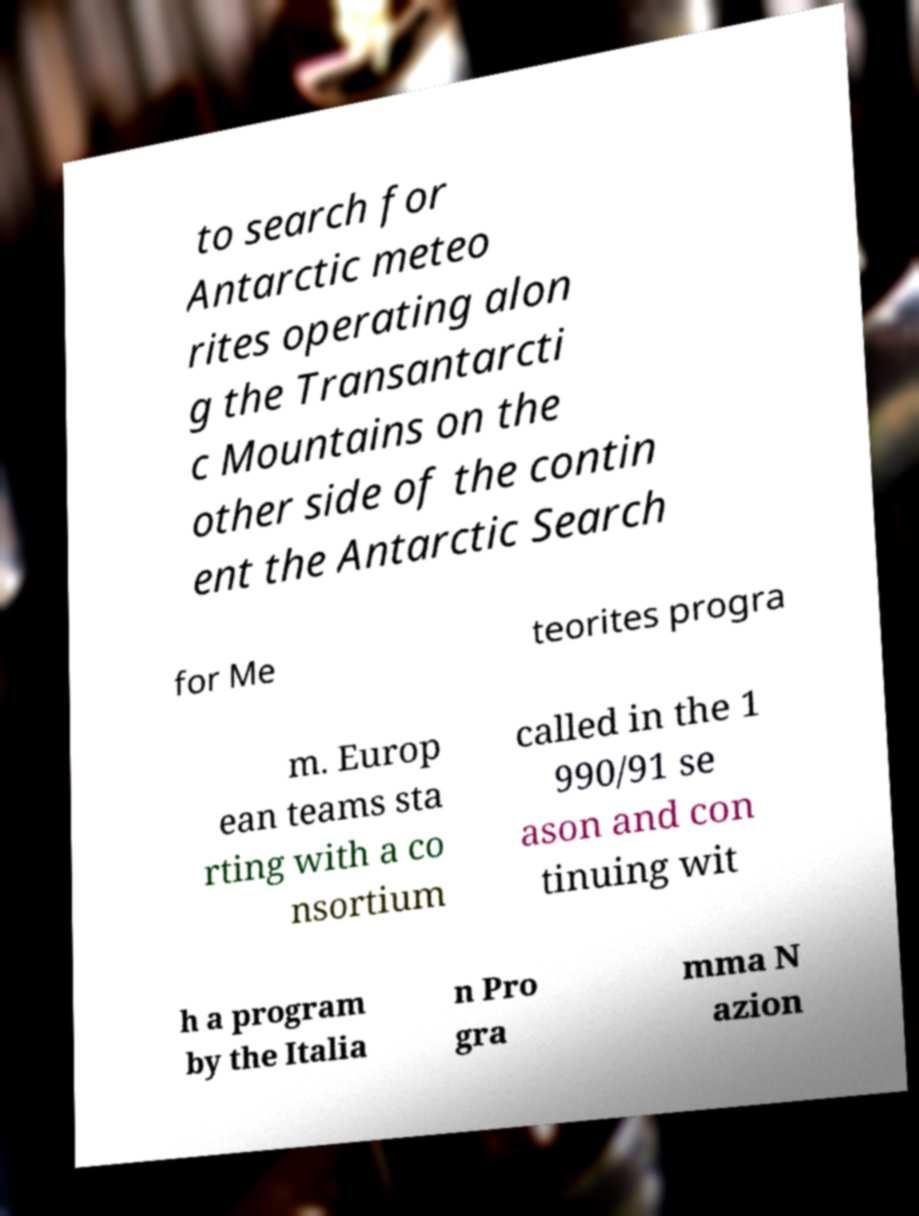Can you accurately transcribe the text from the provided image for me? to search for Antarctic meteo rites operating alon g the Transantarcti c Mountains on the other side of the contin ent the Antarctic Search for Me teorites progra m. Europ ean teams sta rting with a co nsortium called in the 1 990/91 se ason and con tinuing wit h a program by the Italia n Pro gra mma N azion 